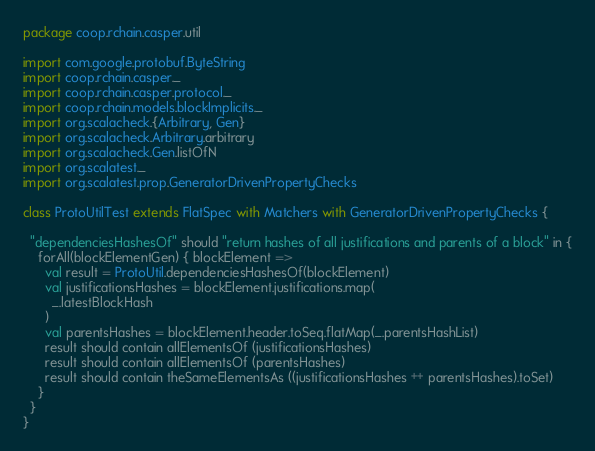Convert code to text. <code><loc_0><loc_0><loc_500><loc_500><_Scala_>package coop.rchain.casper.util

import com.google.protobuf.ByteString
import coop.rchain.casper._
import coop.rchain.casper.protocol._
import coop.rchain.models.blockImplicits._
import org.scalacheck.{Arbitrary, Gen}
import org.scalacheck.Arbitrary.arbitrary
import org.scalacheck.Gen.listOfN
import org.scalatest._
import org.scalatest.prop.GeneratorDrivenPropertyChecks

class ProtoUtilTest extends FlatSpec with Matchers with GeneratorDrivenPropertyChecks {

  "dependenciesHashesOf" should "return hashes of all justifications and parents of a block" in {
    forAll(blockElementGen) { blockElement =>
      val result = ProtoUtil.dependenciesHashesOf(blockElement)
      val justificationsHashes = blockElement.justifications.map(
        _.latestBlockHash
      )
      val parentsHashes = blockElement.header.toSeq.flatMap(_.parentsHashList)
      result should contain allElementsOf (justificationsHashes)
      result should contain allElementsOf (parentsHashes)
      result should contain theSameElementsAs ((justificationsHashes ++ parentsHashes).toSet)
    }
  }
}
</code> 